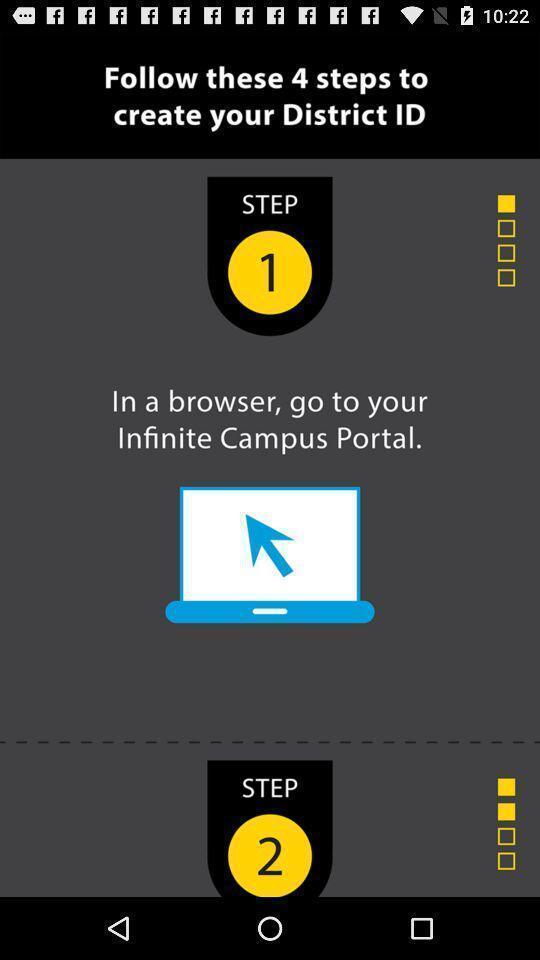Describe the content in this image. Screen displaying steps to access an application. 